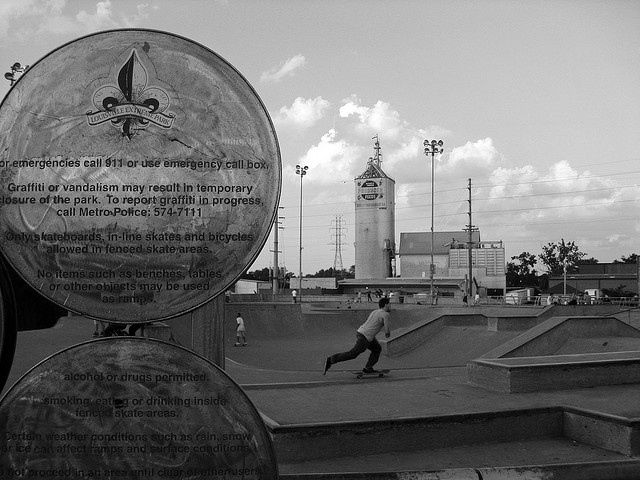Describe the objects in this image and their specific colors. I can see people in gray, black, and lightgray tones, truck in lightgray, gray, darkgray, and black tones, skateboard in black and lightgray tones, people in lightgray, black, and gray tones, and truck in lightgray, gray, black, and darkgray tones in this image. 